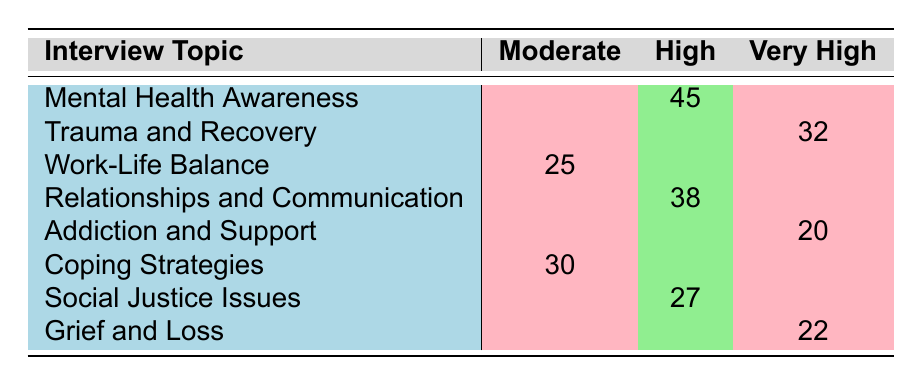What is the emotional impact level for "Work-Life Balance"? The table indicates the emotional impact levels for each interview topic. According to the row for "Work-Life Balance," the emotional impact level is categorized as "Moderate."
Answer: Moderate How many participants reported a high emotional impact for "Mental Health Awareness"? Referring directly to the row for "Mental Health Awareness," the count for high emotional impact is stated as 45 participants.
Answer: 45 Which interview topic has the highest reported count in the "Very High" emotional impact category? Examining the "Very High" category, the topics listed are "Trauma and Recovery" with 32, "Addiction and Support" with 20, and "Grief and Loss" with 22. "Trauma and Recovery" has the highest count at 32.
Answer: Trauma and Recovery What is the total number of participants reporting a "Moderate" emotional impact? To find the total count for "Moderate," sum up the counts in the respective rows: 25 (Work-Life Balance) + 30 (Coping Strategies) = 55. The total number of participants reporting a "Moderate" emotional impact is 55.
Answer: 55 Is it true that there are more topics with a "Very High" emotional impact than those with a "Moderate" impact? There are three topics listed under "Very High" (Trauma and Recovery, Addiction and Support, Grief and Loss) and three topics under "Moderate" (Work-Life Balance, Coping Strategies). Therefore, the statement is false as both categories have the same number of topics.
Answer: No What is the difference in counts between the "High" and "Moderate" emotional impact categories? For "High," the counts are 45 (Mental Health Awareness) + 38 (Relationships and Communication) + 27 (Social Justice Issues) = 110. For "Moderate," the counts are 25 (Work-Life Balance) + 30 (Coping Strategies) = 55. The difference is 110 - 55 = 55.
Answer: 55 Which emotional impact category has the least number of participants, and what is that number? By comparing across the categories, the "Very High" category has counts of 32 (Trauma and Recovery), 20 (Addiction and Support), and 22 (Grief and Loss), totaling 74, while "Moderate" totals 55, and "High" totals 110. Therefore, "Very High" has the least at 74.
Answer: 74 How many participants reported a "High" emotional impact in total? The total number for "High" is calculated as follows: 45 (Mental Health Awareness) + 38 (Relationships and Communication) + 27 (Social Justice Issues) = 110. Thus, the total number of participants reporting a "High" emotional impact is 110.
Answer: 110 